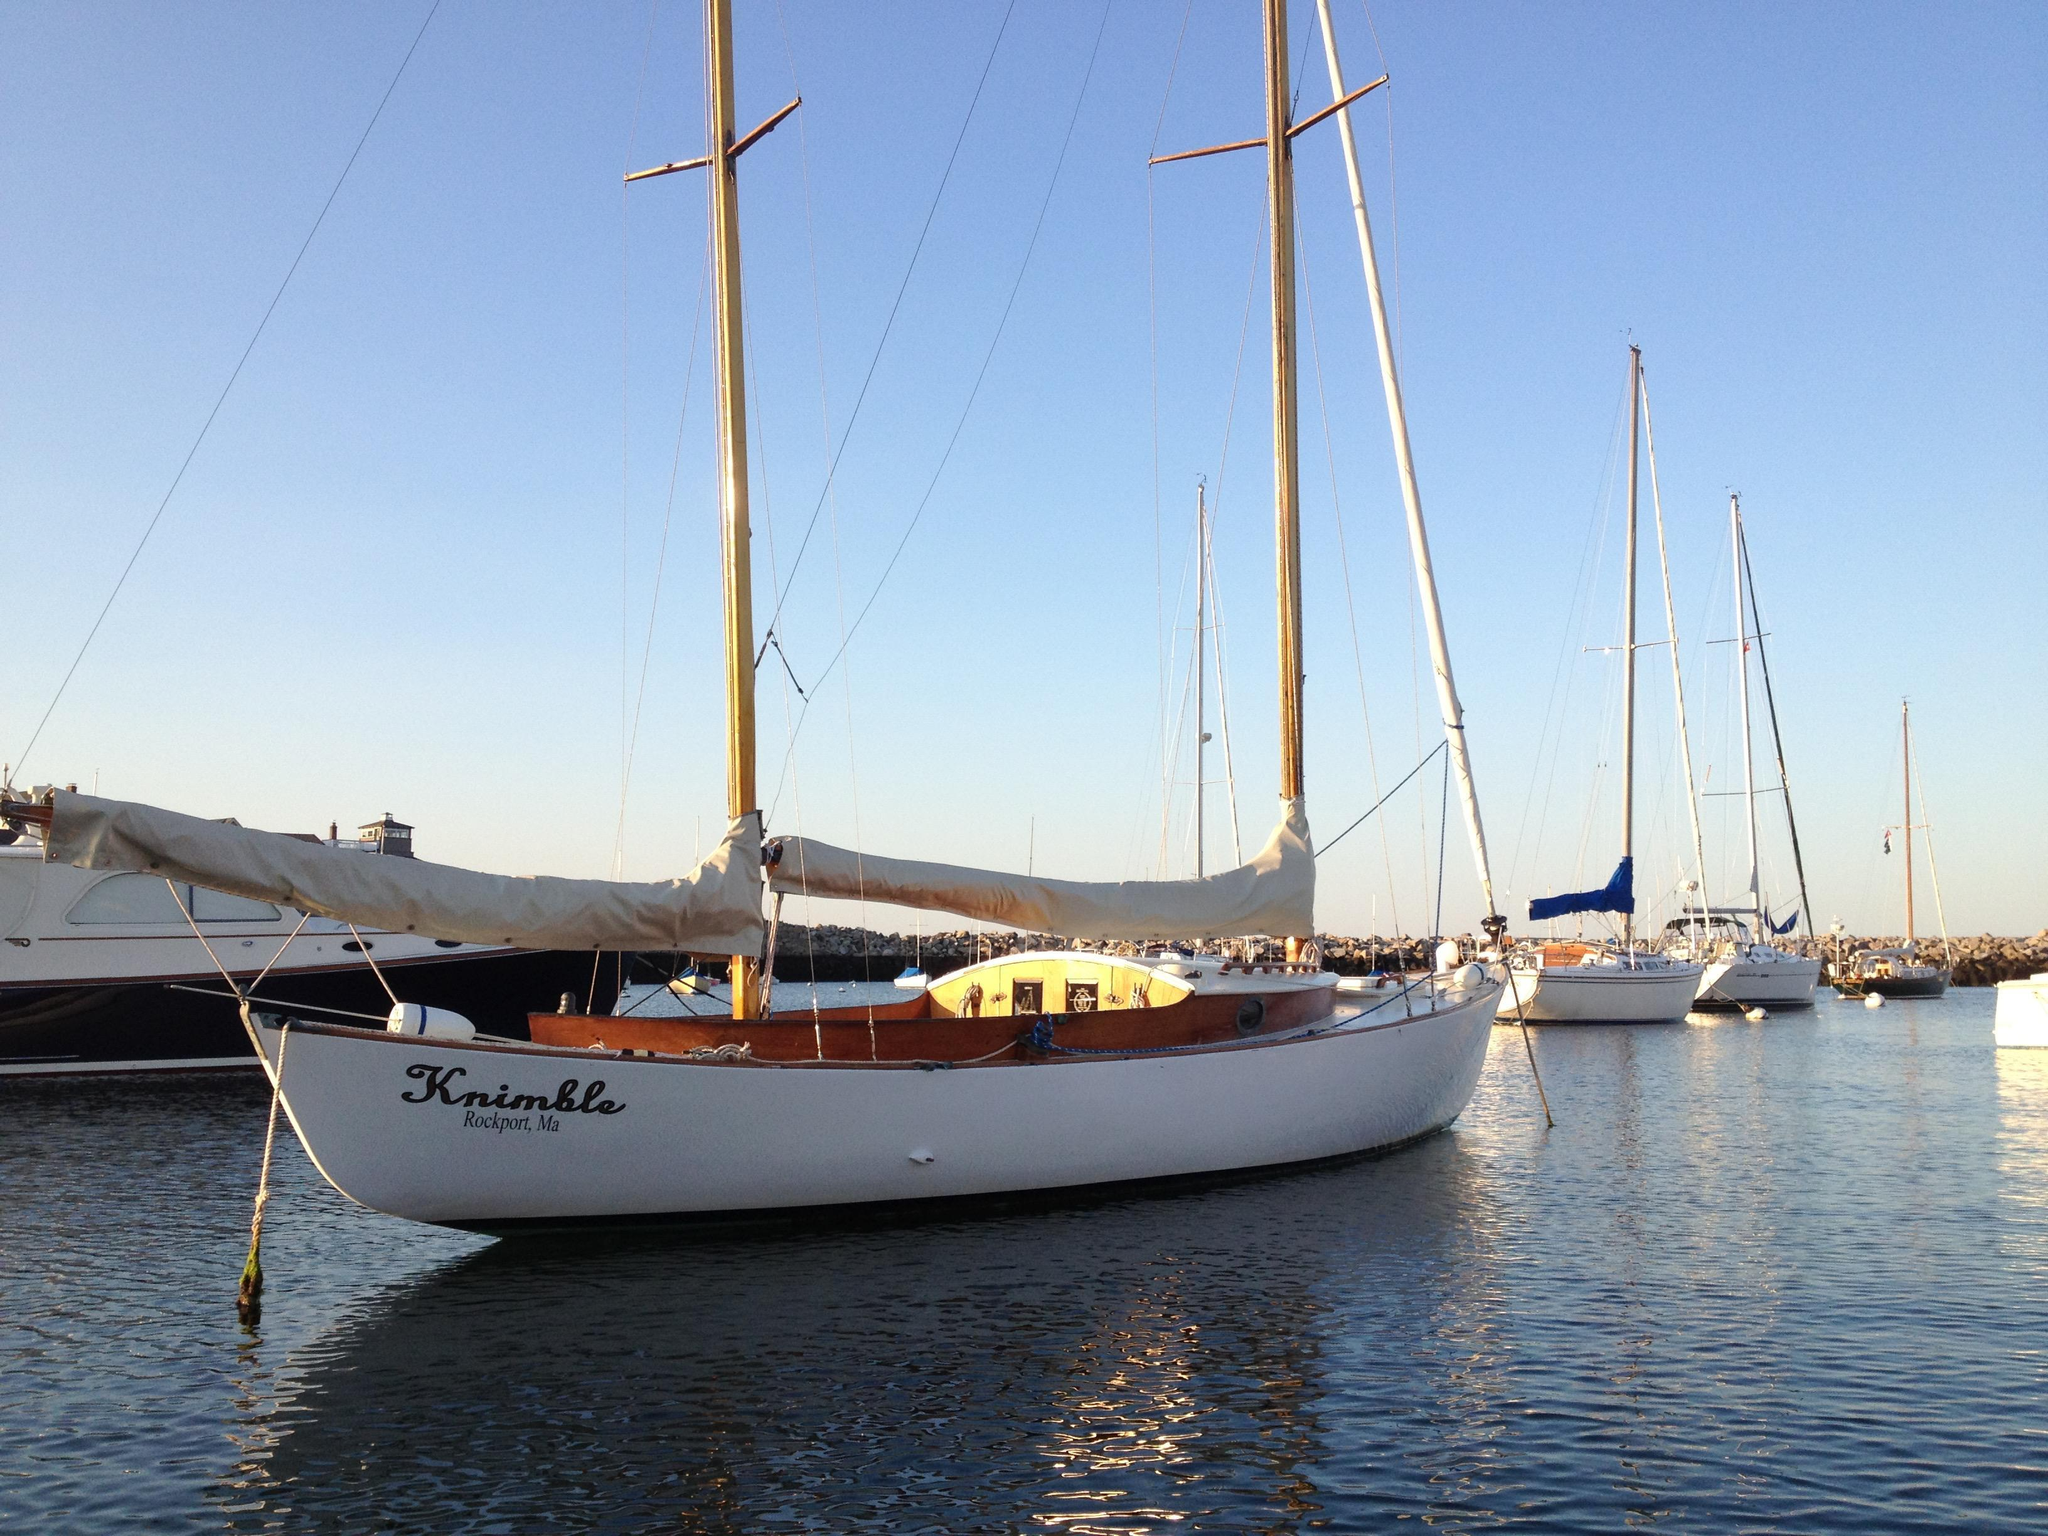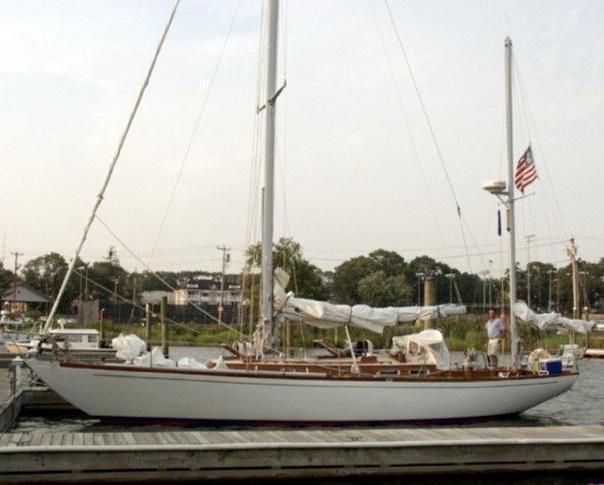The first image is the image on the left, the second image is the image on the right. For the images displayed, is the sentence "People are in two sailboats in the water in one of the images." factually correct? Answer yes or no. No. The first image is the image on the left, the second image is the image on the right. Assess this claim about the two images: "One image shows at least one sailboat with unfurled sails, and the other image shows a boat with furled sails that is not next to a dock.". Correct or not? Answer yes or no. No. 